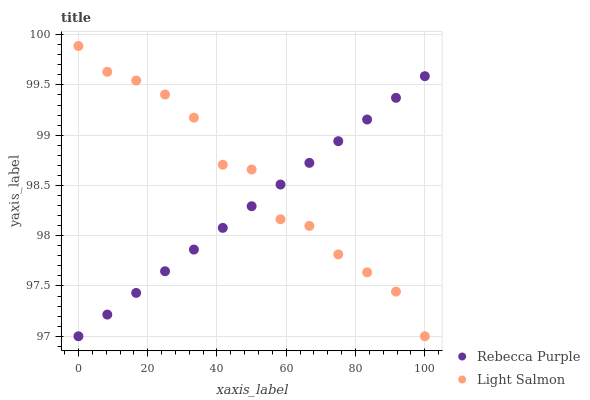Does Rebecca Purple have the minimum area under the curve?
Answer yes or no. Yes. Does Light Salmon have the maximum area under the curve?
Answer yes or no. Yes. Does Rebecca Purple have the maximum area under the curve?
Answer yes or no. No. Is Rebecca Purple the smoothest?
Answer yes or no. Yes. Is Light Salmon the roughest?
Answer yes or no. Yes. Is Rebecca Purple the roughest?
Answer yes or no. No. Does Light Salmon have the lowest value?
Answer yes or no. Yes. Does Light Salmon have the highest value?
Answer yes or no. Yes. Does Rebecca Purple have the highest value?
Answer yes or no. No. Does Rebecca Purple intersect Light Salmon?
Answer yes or no. Yes. Is Rebecca Purple less than Light Salmon?
Answer yes or no. No. Is Rebecca Purple greater than Light Salmon?
Answer yes or no. No. 